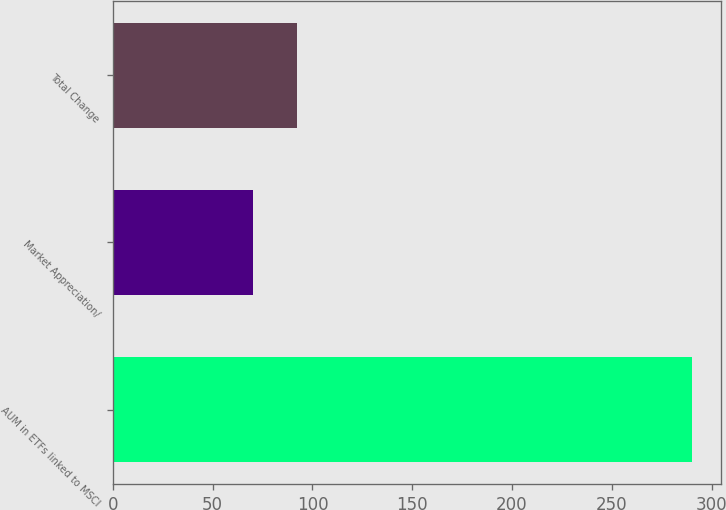Convert chart. <chart><loc_0><loc_0><loc_500><loc_500><bar_chart><fcel>AUM in ETFs linked to MSCI<fcel>Market Appreciation/<fcel>Total Change<nl><fcel>290.1<fcel>70.4<fcel>92.37<nl></chart> 